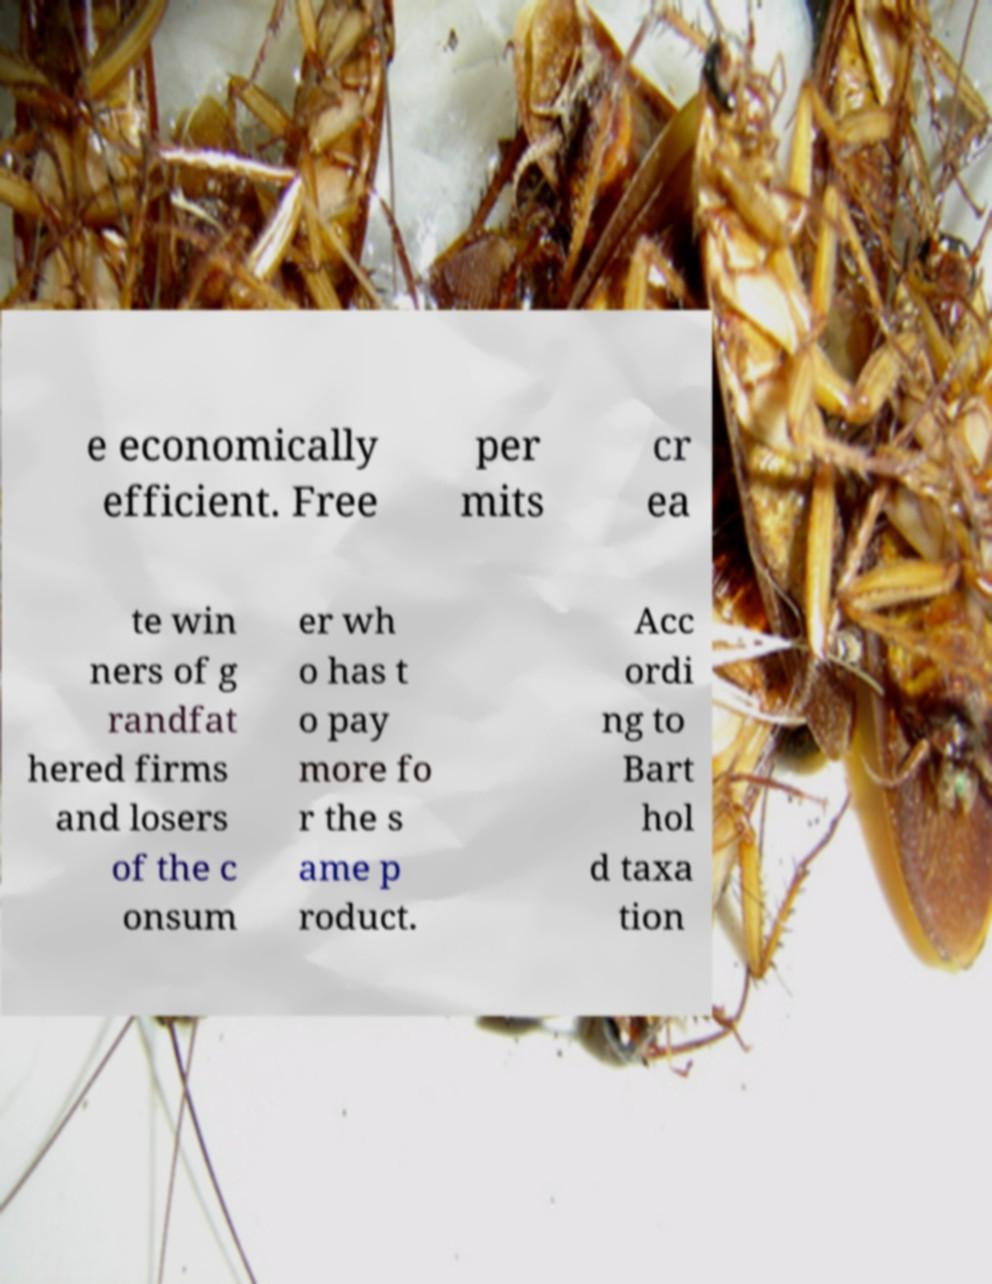I need the written content from this picture converted into text. Can you do that? e economically efficient. Free per mits cr ea te win ners of g randfat hered firms and losers of the c onsum er wh o has t o pay more fo r the s ame p roduct. Acc ordi ng to Bart hol d taxa tion 